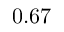<formula> <loc_0><loc_0><loc_500><loc_500>0 . 6 7</formula> 